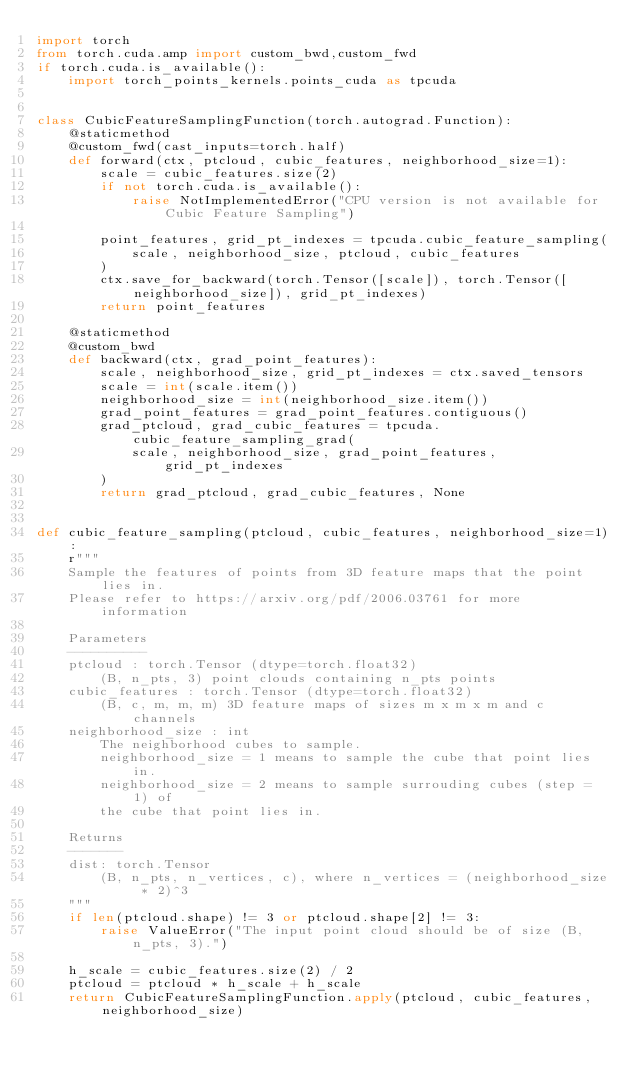Convert code to text. <code><loc_0><loc_0><loc_500><loc_500><_Python_>import torch
from torch.cuda.amp import custom_bwd,custom_fwd
if torch.cuda.is_available():
    import torch_points_kernels.points_cuda as tpcuda


class CubicFeatureSamplingFunction(torch.autograd.Function):
    @staticmethod
    @custom_fwd(cast_inputs=torch.half)
    def forward(ctx, ptcloud, cubic_features, neighborhood_size=1):
        scale = cubic_features.size(2)
        if not torch.cuda.is_available():
            raise NotImplementedError("CPU version is not available for Cubic Feature Sampling")

        point_features, grid_pt_indexes = tpcuda.cubic_feature_sampling(
            scale, neighborhood_size, ptcloud, cubic_features
        )
        ctx.save_for_backward(torch.Tensor([scale]), torch.Tensor([neighborhood_size]), grid_pt_indexes)
        return point_features

    @staticmethod
    @custom_bwd
    def backward(ctx, grad_point_features):
        scale, neighborhood_size, grid_pt_indexes = ctx.saved_tensors
        scale = int(scale.item())
        neighborhood_size = int(neighborhood_size.item())
        grad_point_features = grad_point_features.contiguous()
        grad_ptcloud, grad_cubic_features = tpcuda.cubic_feature_sampling_grad(
            scale, neighborhood_size, grad_point_features, grid_pt_indexes
        )
        return grad_ptcloud, grad_cubic_features, None


def cubic_feature_sampling(ptcloud, cubic_features, neighborhood_size=1):
    r"""
    Sample the features of points from 3D feature maps that the point lies in.
    Please refer to https://arxiv.org/pdf/2006.03761 for more information

    Parameters
    ----------
    ptcloud : torch.Tensor (dtype=torch.float32)
        (B, n_pts, 3) point clouds containing n_pts points
    cubic_features : torch.Tensor (dtype=torch.float32)
        (B, c, m, m, m) 3D feature maps of sizes m x m x m and c channels
    neighborhood_size : int
        The neighborhood cubes to sample.
        neighborhood_size = 1 means to sample the cube that point lies in.
        neighborhood_size = 2 means to sample surrouding cubes (step = 1) of
        the cube that point lies in.

    Returns
    -------
    dist: torch.Tensor
        (B, n_pts, n_vertices, c), where n_vertices = (neighborhood_size * 2)^3
    """
    if len(ptcloud.shape) != 3 or ptcloud.shape[2] != 3:
        raise ValueError("The input point cloud should be of size (B, n_pts, 3).")

    h_scale = cubic_features.size(2) / 2
    ptcloud = ptcloud * h_scale + h_scale
    return CubicFeatureSamplingFunction.apply(ptcloud, cubic_features, neighborhood_size)
</code> 